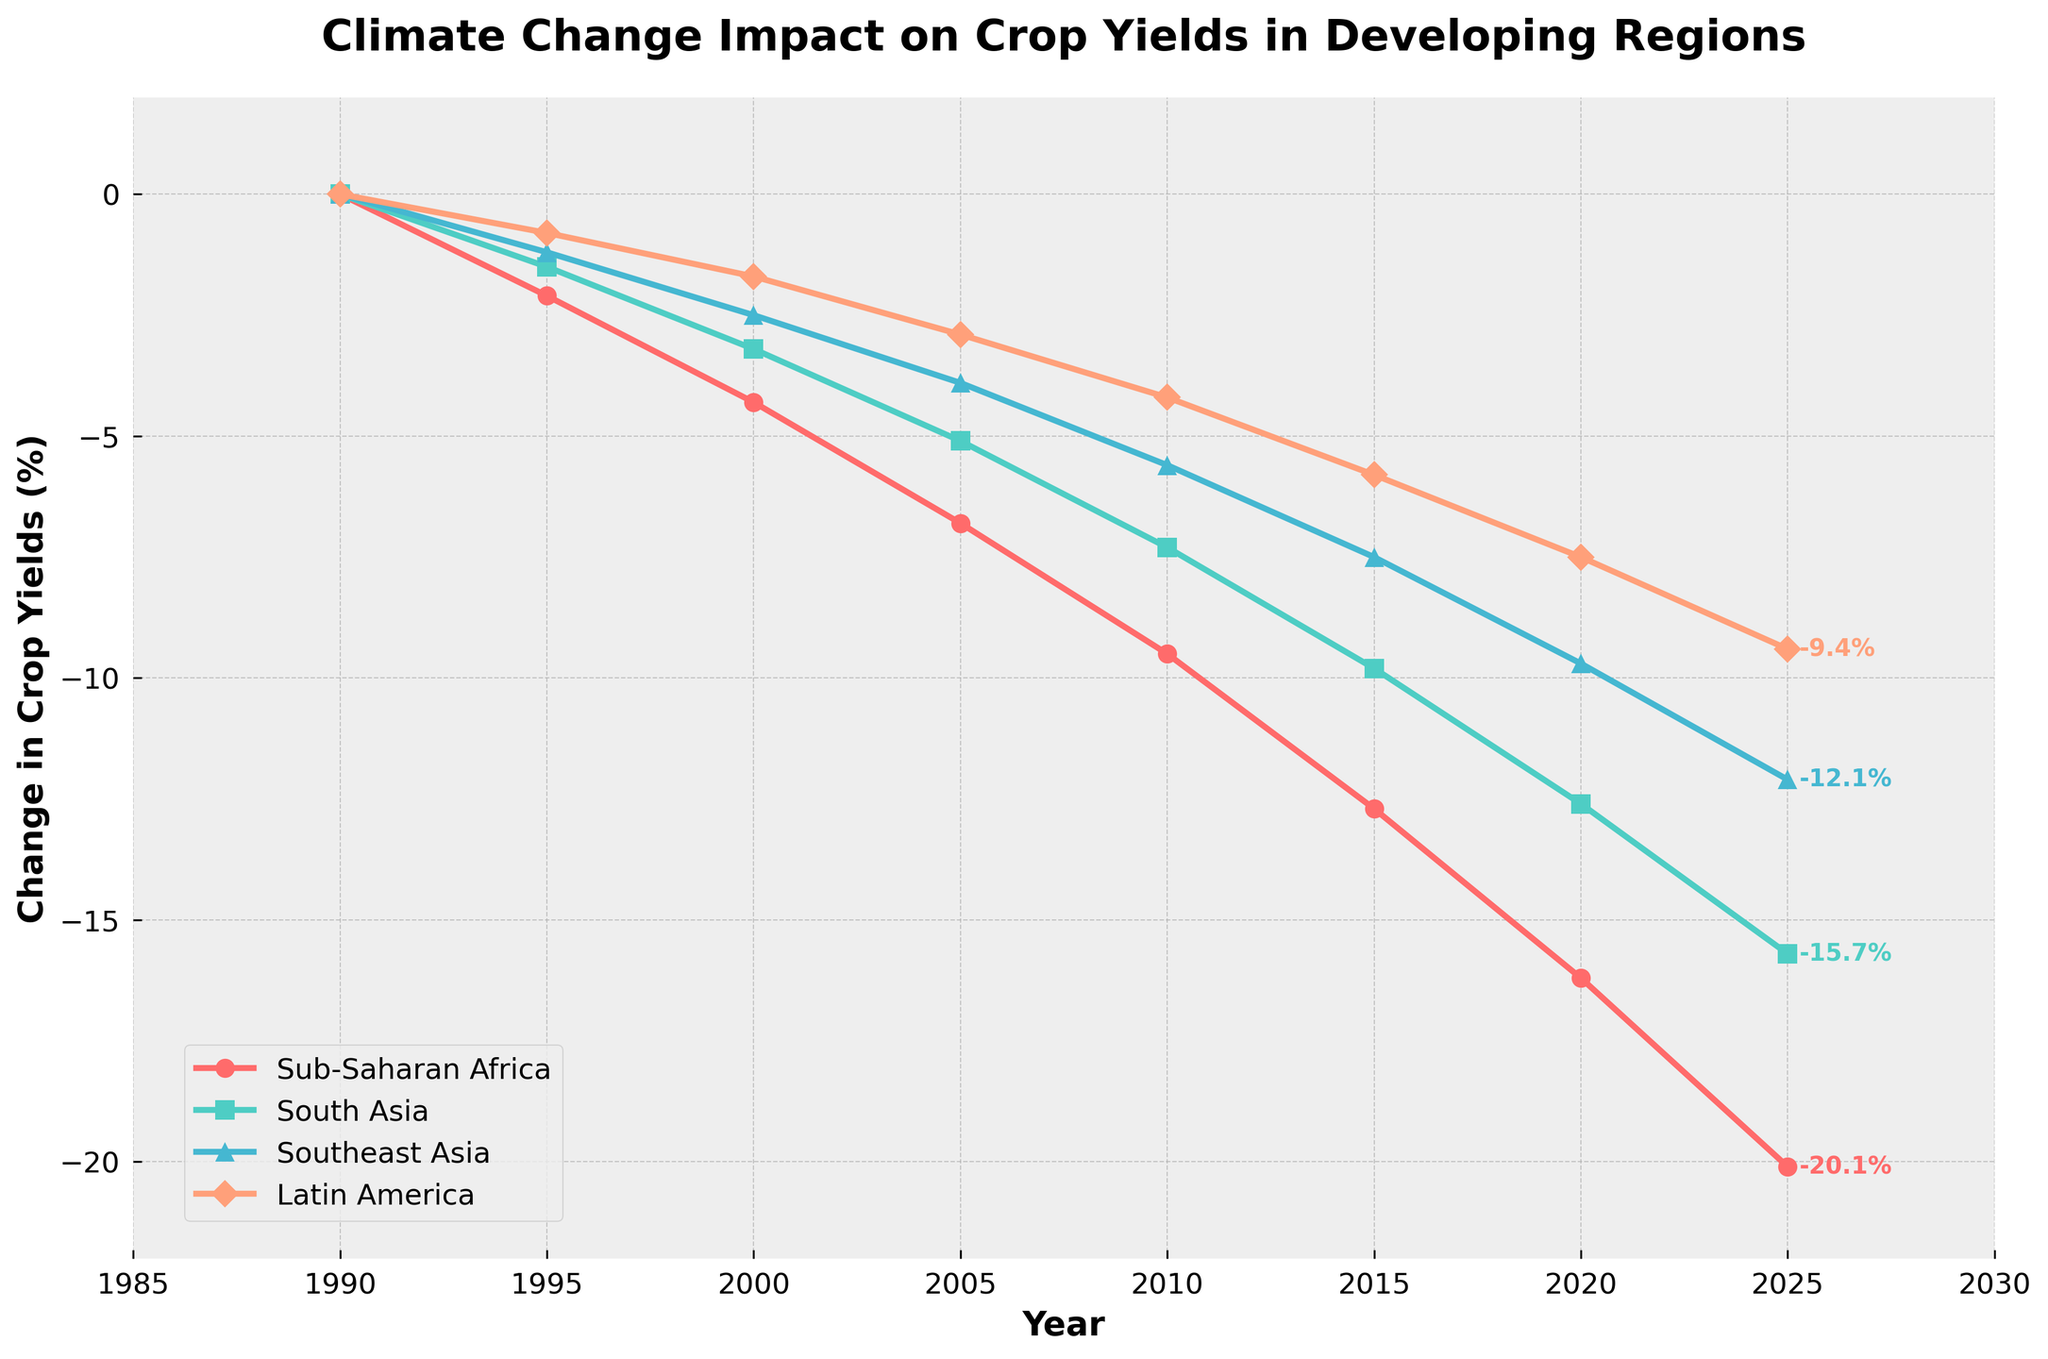What is the overall trend in crop yields for Sub-Saharan Africa from 1990 to 2025? The overall trend in crop yields for Sub-Saharan Africa is a steady decline. Starting at 0% change in 1990, it decreases over the years, reaching around -20.1% by 2025.
Answer: A steady decline Which region shows the steepest decline in crop yields from 1990 to 2025? To determine the steepest decline, compare the changes for all regions between 1990 and 2025. Sub-Saharan Africa drops from 0% to about -20.1%, which is the largest negative change.
Answer: Sub-Saharan Africa By how much do the crop yields change in South Asia from 2000 to 2010? The change in crop yields for South Asia from 2000 to 2010 is the difference between the values for these years: -7.3% (2010) - (-3.2% (2000)) = -4.1%.
Answer: -4.1% Which region had the least change in crop yields in the year 2005? In 2005, the changes in crop yields are -6.8% for Sub-Saharan Africa, -5.1% for South Asia, -3.9% for Southeast Asia, and -2.9% for Latin America. The least change is -2.9% in Latin America.
Answer: Latin America How does the change in crop yields in 2025 for Latin America compare to that in Southeast Asia? In 2025, the change in Latin America is -9.4%, while in Southeast Asia it is -12.1%. Latin America has a smaller negative change than Southeast Asia.
Answer: Latin America has a smaller negative change What is the average change in crop yields for Southeast Asia from 1990 to 2025? To find the average change in crop yields for Southeast Asia, sum the percentage changes for all years and divide by the number of data points: (0 - 1.2 - 2.5 - 3.9 - 5.6 - 7.5 - 9.7 - 12.1) / 8 = -5.31%.
Answer: -5.31% Is there a point where crop yields in Sub-Saharan Africa and South Asia were equal? Throughout the years, the data shows distinct negative values for both Sub-Saharan Africa and South Asia. They do not intersect; Sub-Saharan Africa consistently has a larger decline.
Answer: No How does the color representation help in differentiating the regions? The line plot uses different colors: red for Sub-Saharan Africa, turquoise for South Asia, blue for Southeast Asia, and salmon for Latin America, making it easy to distinguish among the regions.
Answer: Different colors What is the change in crop yields for Sub-Saharan Africa in 2010 compared to 1990? The change in crop yields for Sub-Saharan Africa from 1990 (0%) to 2010 (-9.5%) is -9.5%.
Answer: -9.5% 